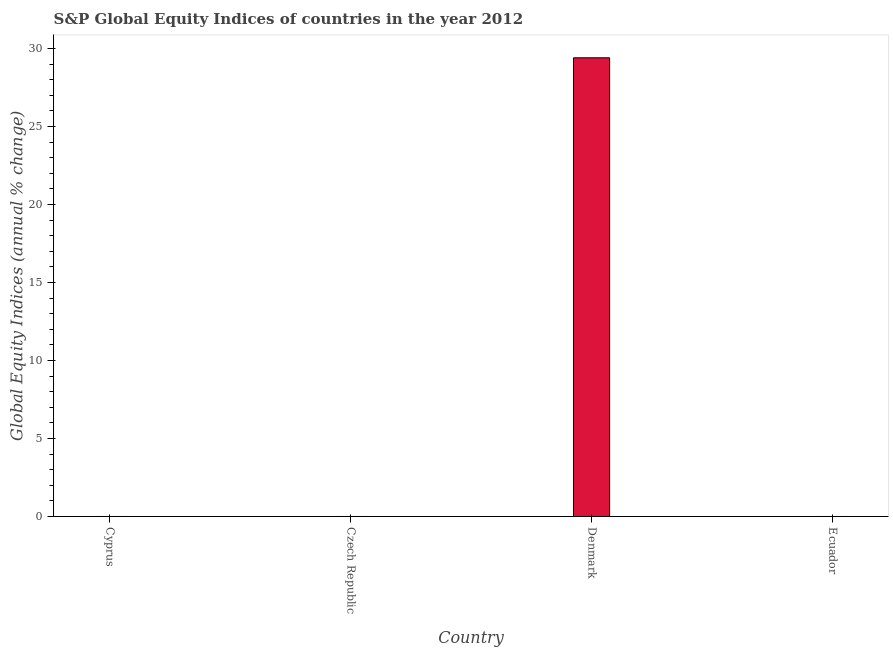Does the graph contain any zero values?
Give a very brief answer. Yes. Does the graph contain grids?
Your response must be concise. No. What is the title of the graph?
Provide a short and direct response. S&P Global Equity Indices of countries in the year 2012. What is the label or title of the X-axis?
Offer a very short reply. Country. What is the label or title of the Y-axis?
Your answer should be very brief. Global Equity Indices (annual % change). What is the s&p global equity indices in Czech Republic?
Your answer should be very brief. 0. Across all countries, what is the maximum s&p global equity indices?
Your answer should be very brief. 29.4. What is the sum of the s&p global equity indices?
Provide a succinct answer. 29.4. What is the average s&p global equity indices per country?
Ensure brevity in your answer.  7.35. In how many countries, is the s&p global equity indices greater than 24 %?
Ensure brevity in your answer.  1. What is the difference between the highest and the lowest s&p global equity indices?
Make the answer very short. 29.4. How many countries are there in the graph?
Keep it short and to the point. 4. What is the difference between two consecutive major ticks on the Y-axis?
Provide a succinct answer. 5. Are the values on the major ticks of Y-axis written in scientific E-notation?
Your answer should be compact. No. What is the Global Equity Indices (annual % change) in Cyprus?
Offer a terse response. 0. What is the Global Equity Indices (annual % change) in Denmark?
Offer a terse response. 29.4. 